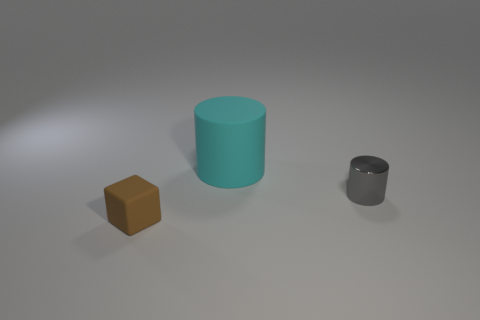Is there any other thing that is made of the same material as the small gray cylinder?
Ensure brevity in your answer.  No. Is there anything else that is the same size as the cyan cylinder?
Keep it short and to the point. No. What number of matte objects are large cyan objects or small brown objects?
Provide a short and direct response. 2. Are any tiny purple matte blocks visible?
Keep it short and to the point. No. Is the shape of the big matte object the same as the brown rubber thing?
Offer a very short reply. No. There is a rubber thing that is right of the matte thing that is left of the large rubber cylinder; what number of large rubber objects are to the right of it?
Offer a terse response. 0. The object that is in front of the cyan matte cylinder and behind the small brown matte thing is made of what material?
Provide a succinct answer. Metal. What is the color of the object that is behind the small brown object and in front of the large cyan cylinder?
Make the answer very short. Gray. There is a thing to the right of the thing behind the small thing behind the brown matte block; what is its shape?
Your answer should be compact. Cylinder. What color is the small metallic thing that is the same shape as the cyan matte thing?
Give a very brief answer. Gray. 